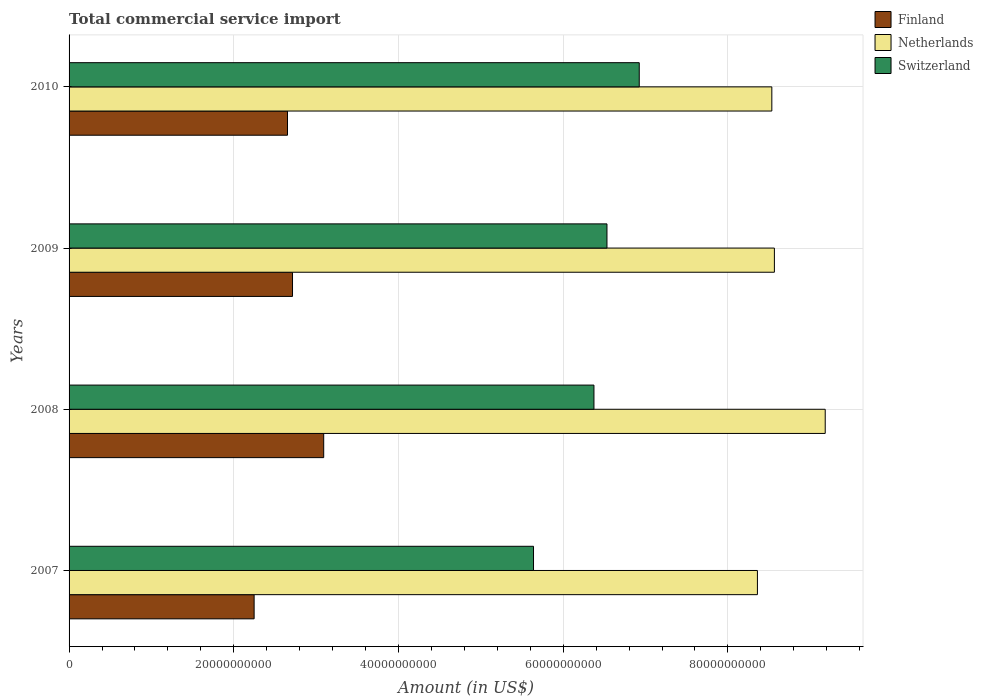How many different coloured bars are there?
Your response must be concise. 3. How many groups of bars are there?
Offer a very short reply. 4. Are the number of bars per tick equal to the number of legend labels?
Ensure brevity in your answer.  Yes. In how many cases, is the number of bars for a given year not equal to the number of legend labels?
Offer a very short reply. 0. What is the total commercial service import in Finland in 2009?
Give a very brief answer. 2.71e+1. Across all years, what is the maximum total commercial service import in Finland?
Ensure brevity in your answer.  3.09e+1. Across all years, what is the minimum total commercial service import in Finland?
Offer a very short reply. 2.25e+1. In which year was the total commercial service import in Switzerland maximum?
Make the answer very short. 2010. In which year was the total commercial service import in Finland minimum?
Your answer should be compact. 2007. What is the total total commercial service import in Netherlands in the graph?
Provide a succinct answer. 3.46e+11. What is the difference between the total commercial service import in Switzerland in 2008 and that in 2010?
Your answer should be very brief. -5.50e+09. What is the difference between the total commercial service import in Finland in 2009 and the total commercial service import in Switzerland in 2007?
Provide a succinct answer. -2.93e+1. What is the average total commercial service import in Netherlands per year?
Make the answer very short. 8.66e+1. In the year 2007, what is the difference between the total commercial service import in Finland and total commercial service import in Switzerland?
Offer a terse response. -3.39e+1. What is the ratio of the total commercial service import in Netherlands in 2008 to that in 2009?
Provide a succinct answer. 1.07. What is the difference between the highest and the second highest total commercial service import in Finland?
Offer a terse response. 3.79e+09. What is the difference between the highest and the lowest total commercial service import in Switzerland?
Make the answer very short. 1.28e+1. What does the 1st bar from the top in 2010 represents?
Provide a succinct answer. Switzerland. What does the 3rd bar from the bottom in 2010 represents?
Your response must be concise. Switzerland. How many bars are there?
Offer a terse response. 12. Are all the bars in the graph horizontal?
Make the answer very short. Yes. What is the difference between two consecutive major ticks on the X-axis?
Keep it short and to the point. 2.00e+1. Where does the legend appear in the graph?
Offer a terse response. Top right. How are the legend labels stacked?
Your response must be concise. Vertical. What is the title of the graph?
Give a very brief answer. Total commercial service import. Does "Moldova" appear as one of the legend labels in the graph?
Provide a short and direct response. No. What is the Amount (in US$) of Finland in 2007?
Your response must be concise. 2.25e+1. What is the Amount (in US$) of Netherlands in 2007?
Offer a terse response. 8.36e+1. What is the Amount (in US$) in Switzerland in 2007?
Make the answer very short. 5.64e+1. What is the Amount (in US$) in Finland in 2008?
Offer a terse response. 3.09e+1. What is the Amount (in US$) in Netherlands in 2008?
Offer a terse response. 9.18e+1. What is the Amount (in US$) of Switzerland in 2008?
Offer a very short reply. 6.37e+1. What is the Amount (in US$) in Finland in 2009?
Make the answer very short. 2.71e+1. What is the Amount (in US$) in Netherlands in 2009?
Offer a terse response. 8.56e+1. What is the Amount (in US$) of Switzerland in 2009?
Ensure brevity in your answer.  6.53e+1. What is the Amount (in US$) of Finland in 2010?
Your answer should be very brief. 2.65e+1. What is the Amount (in US$) of Netherlands in 2010?
Ensure brevity in your answer.  8.53e+1. What is the Amount (in US$) of Switzerland in 2010?
Provide a short and direct response. 6.92e+1. Across all years, what is the maximum Amount (in US$) in Finland?
Your answer should be compact. 3.09e+1. Across all years, what is the maximum Amount (in US$) of Netherlands?
Your answer should be very brief. 9.18e+1. Across all years, what is the maximum Amount (in US$) of Switzerland?
Offer a terse response. 6.92e+1. Across all years, what is the minimum Amount (in US$) of Finland?
Make the answer very short. 2.25e+1. Across all years, what is the minimum Amount (in US$) of Netherlands?
Give a very brief answer. 8.36e+1. Across all years, what is the minimum Amount (in US$) in Switzerland?
Give a very brief answer. 5.64e+1. What is the total Amount (in US$) of Finland in the graph?
Make the answer very short. 1.07e+11. What is the total Amount (in US$) of Netherlands in the graph?
Offer a terse response. 3.46e+11. What is the total Amount (in US$) in Switzerland in the graph?
Provide a short and direct response. 2.55e+11. What is the difference between the Amount (in US$) in Finland in 2007 and that in 2008?
Your answer should be compact. -8.45e+09. What is the difference between the Amount (in US$) in Netherlands in 2007 and that in 2008?
Give a very brief answer. -8.23e+09. What is the difference between the Amount (in US$) of Switzerland in 2007 and that in 2008?
Give a very brief answer. -7.34e+09. What is the difference between the Amount (in US$) in Finland in 2007 and that in 2009?
Your response must be concise. -4.66e+09. What is the difference between the Amount (in US$) of Netherlands in 2007 and that in 2009?
Ensure brevity in your answer.  -2.06e+09. What is the difference between the Amount (in US$) in Switzerland in 2007 and that in 2009?
Keep it short and to the point. -8.92e+09. What is the difference between the Amount (in US$) of Finland in 2007 and that in 2010?
Make the answer very short. -4.05e+09. What is the difference between the Amount (in US$) of Netherlands in 2007 and that in 2010?
Offer a terse response. -1.75e+09. What is the difference between the Amount (in US$) of Switzerland in 2007 and that in 2010?
Keep it short and to the point. -1.28e+1. What is the difference between the Amount (in US$) of Finland in 2008 and that in 2009?
Your answer should be compact. 3.79e+09. What is the difference between the Amount (in US$) in Netherlands in 2008 and that in 2009?
Offer a very short reply. 6.17e+09. What is the difference between the Amount (in US$) in Switzerland in 2008 and that in 2009?
Provide a succinct answer. -1.58e+09. What is the difference between the Amount (in US$) in Finland in 2008 and that in 2010?
Give a very brief answer. 4.40e+09. What is the difference between the Amount (in US$) in Netherlands in 2008 and that in 2010?
Offer a terse response. 6.48e+09. What is the difference between the Amount (in US$) in Switzerland in 2008 and that in 2010?
Keep it short and to the point. -5.50e+09. What is the difference between the Amount (in US$) in Finland in 2009 and that in 2010?
Keep it short and to the point. 6.09e+08. What is the difference between the Amount (in US$) in Netherlands in 2009 and that in 2010?
Make the answer very short. 3.13e+08. What is the difference between the Amount (in US$) in Switzerland in 2009 and that in 2010?
Provide a succinct answer. -3.92e+09. What is the difference between the Amount (in US$) in Finland in 2007 and the Amount (in US$) in Netherlands in 2008?
Keep it short and to the point. -6.93e+1. What is the difference between the Amount (in US$) of Finland in 2007 and the Amount (in US$) of Switzerland in 2008?
Offer a very short reply. -4.13e+1. What is the difference between the Amount (in US$) of Netherlands in 2007 and the Amount (in US$) of Switzerland in 2008?
Ensure brevity in your answer.  1.98e+1. What is the difference between the Amount (in US$) in Finland in 2007 and the Amount (in US$) in Netherlands in 2009?
Offer a terse response. -6.32e+1. What is the difference between the Amount (in US$) in Finland in 2007 and the Amount (in US$) in Switzerland in 2009?
Your answer should be very brief. -4.28e+1. What is the difference between the Amount (in US$) in Netherlands in 2007 and the Amount (in US$) in Switzerland in 2009?
Keep it short and to the point. 1.83e+1. What is the difference between the Amount (in US$) of Finland in 2007 and the Amount (in US$) of Netherlands in 2010?
Offer a terse response. -6.29e+1. What is the difference between the Amount (in US$) in Finland in 2007 and the Amount (in US$) in Switzerland in 2010?
Keep it short and to the point. -4.68e+1. What is the difference between the Amount (in US$) of Netherlands in 2007 and the Amount (in US$) of Switzerland in 2010?
Your answer should be very brief. 1.43e+1. What is the difference between the Amount (in US$) of Finland in 2008 and the Amount (in US$) of Netherlands in 2009?
Give a very brief answer. -5.47e+1. What is the difference between the Amount (in US$) of Finland in 2008 and the Amount (in US$) of Switzerland in 2009?
Make the answer very short. -3.44e+1. What is the difference between the Amount (in US$) of Netherlands in 2008 and the Amount (in US$) of Switzerland in 2009?
Your response must be concise. 2.65e+1. What is the difference between the Amount (in US$) in Finland in 2008 and the Amount (in US$) in Netherlands in 2010?
Provide a succinct answer. -5.44e+1. What is the difference between the Amount (in US$) in Finland in 2008 and the Amount (in US$) in Switzerland in 2010?
Keep it short and to the point. -3.83e+1. What is the difference between the Amount (in US$) in Netherlands in 2008 and the Amount (in US$) in Switzerland in 2010?
Make the answer very short. 2.26e+1. What is the difference between the Amount (in US$) of Finland in 2009 and the Amount (in US$) of Netherlands in 2010?
Your response must be concise. -5.82e+1. What is the difference between the Amount (in US$) of Finland in 2009 and the Amount (in US$) of Switzerland in 2010?
Your answer should be very brief. -4.21e+1. What is the difference between the Amount (in US$) of Netherlands in 2009 and the Amount (in US$) of Switzerland in 2010?
Keep it short and to the point. 1.64e+1. What is the average Amount (in US$) in Finland per year?
Your response must be concise. 2.68e+1. What is the average Amount (in US$) of Netherlands per year?
Your answer should be very brief. 8.66e+1. What is the average Amount (in US$) in Switzerland per year?
Keep it short and to the point. 6.37e+1. In the year 2007, what is the difference between the Amount (in US$) in Finland and Amount (in US$) in Netherlands?
Your answer should be very brief. -6.11e+1. In the year 2007, what is the difference between the Amount (in US$) in Finland and Amount (in US$) in Switzerland?
Keep it short and to the point. -3.39e+1. In the year 2007, what is the difference between the Amount (in US$) of Netherlands and Amount (in US$) of Switzerland?
Keep it short and to the point. 2.72e+1. In the year 2008, what is the difference between the Amount (in US$) in Finland and Amount (in US$) in Netherlands?
Give a very brief answer. -6.09e+1. In the year 2008, what is the difference between the Amount (in US$) of Finland and Amount (in US$) of Switzerland?
Keep it short and to the point. -3.28e+1. In the year 2008, what is the difference between the Amount (in US$) of Netherlands and Amount (in US$) of Switzerland?
Your answer should be very brief. 2.81e+1. In the year 2009, what is the difference between the Amount (in US$) of Finland and Amount (in US$) of Netherlands?
Offer a terse response. -5.85e+1. In the year 2009, what is the difference between the Amount (in US$) in Finland and Amount (in US$) in Switzerland?
Your response must be concise. -3.82e+1. In the year 2009, what is the difference between the Amount (in US$) of Netherlands and Amount (in US$) of Switzerland?
Offer a very short reply. 2.03e+1. In the year 2010, what is the difference between the Amount (in US$) of Finland and Amount (in US$) of Netherlands?
Make the answer very short. -5.88e+1. In the year 2010, what is the difference between the Amount (in US$) of Finland and Amount (in US$) of Switzerland?
Offer a very short reply. -4.27e+1. In the year 2010, what is the difference between the Amount (in US$) in Netherlands and Amount (in US$) in Switzerland?
Offer a terse response. 1.61e+1. What is the ratio of the Amount (in US$) of Finland in 2007 to that in 2008?
Provide a short and direct response. 0.73. What is the ratio of the Amount (in US$) in Netherlands in 2007 to that in 2008?
Offer a very short reply. 0.91. What is the ratio of the Amount (in US$) of Switzerland in 2007 to that in 2008?
Offer a very short reply. 0.88. What is the ratio of the Amount (in US$) of Finland in 2007 to that in 2009?
Your answer should be compact. 0.83. What is the ratio of the Amount (in US$) in Netherlands in 2007 to that in 2009?
Your answer should be very brief. 0.98. What is the ratio of the Amount (in US$) of Switzerland in 2007 to that in 2009?
Offer a terse response. 0.86. What is the ratio of the Amount (in US$) in Finland in 2007 to that in 2010?
Your response must be concise. 0.85. What is the ratio of the Amount (in US$) of Netherlands in 2007 to that in 2010?
Offer a terse response. 0.98. What is the ratio of the Amount (in US$) of Switzerland in 2007 to that in 2010?
Your answer should be very brief. 0.81. What is the ratio of the Amount (in US$) of Finland in 2008 to that in 2009?
Your answer should be very brief. 1.14. What is the ratio of the Amount (in US$) of Netherlands in 2008 to that in 2009?
Provide a short and direct response. 1.07. What is the ratio of the Amount (in US$) in Switzerland in 2008 to that in 2009?
Your response must be concise. 0.98. What is the ratio of the Amount (in US$) in Finland in 2008 to that in 2010?
Your response must be concise. 1.17. What is the ratio of the Amount (in US$) of Netherlands in 2008 to that in 2010?
Keep it short and to the point. 1.08. What is the ratio of the Amount (in US$) in Switzerland in 2008 to that in 2010?
Offer a very short reply. 0.92. What is the ratio of the Amount (in US$) of Finland in 2009 to that in 2010?
Your answer should be compact. 1.02. What is the ratio of the Amount (in US$) in Switzerland in 2009 to that in 2010?
Make the answer very short. 0.94. What is the difference between the highest and the second highest Amount (in US$) in Finland?
Make the answer very short. 3.79e+09. What is the difference between the highest and the second highest Amount (in US$) of Netherlands?
Ensure brevity in your answer.  6.17e+09. What is the difference between the highest and the second highest Amount (in US$) in Switzerland?
Your answer should be compact. 3.92e+09. What is the difference between the highest and the lowest Amount (in US$) in Finland?
Offer a very short reply. 8.45e+09. What is the difference between the highest and the lowest Amount (in US$) in Netherlands?
Provide a short and direct response. 8.23e+09. What is the difference between the highest and the lowest Amount (in US$) in Switzerland?
Your answer should be very brief. 1.28e+1. 